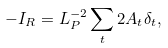<formula> <loc_0><loc_0><loc_500><loc_500>- I _ { R } = L ^ { - 2 } _ { P } \sum _ { t } 2 A _ { t } \delta _ { t } ,</formula> 